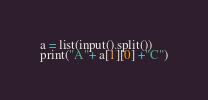Convert code to text. <code><loc_0><loc_0><loc_500><loc_500><_Python_>a = list(input().split())
print("A"+ a[1][0] +"C")
</code> 